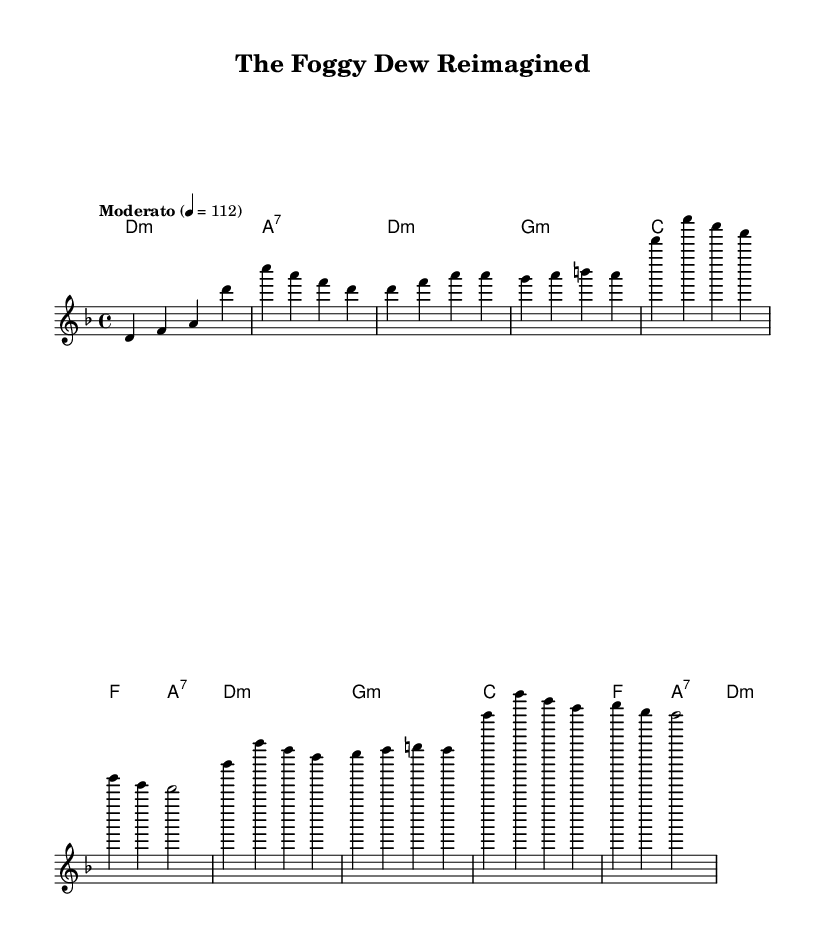What is the key signature of this music? The key signature is specified at the beginning of the sheet music with a "d" followed by "m" which indicates D minor.
Answer: D minor What is the time signature of this music? The time signature is indicated with the fraction "4/4" at the beginning of the piece, meaning there are 4 beats per measure.
Answer: 4/4 What is the tempo marking for this piece? The tempo marking is given in Italian as "Moderato" and a specific beats per minute value of "4 = 112," which directs the performers on the speed of the music.
Answer: Moderato How many measures are in the verse section? The verse section consists of 4 lines in the music, and each line contains 4 measures, summing up to a total of 16 measures. Thus, counting all within the verse indicates there are 4 measures.
Answer: 4 measures What is the first chord used in the music? The first chord is specified in the harmonies section as "d1:m," indicating a D minor chord that is played for the duration of one whole note.
Answer: D minor In the chorus section, what is the final note's pitch? The final note of the chorus section is represented by "d2," meaning it is a D note held for two beats.
Answer: D What instrument is suggested for this score format? The score specifically uses symbols such as "Staff" and "ChordNames," which indicates that it is meant for piano or keyboard instruments to accompany the vocals or melody.
Answer: Piano 